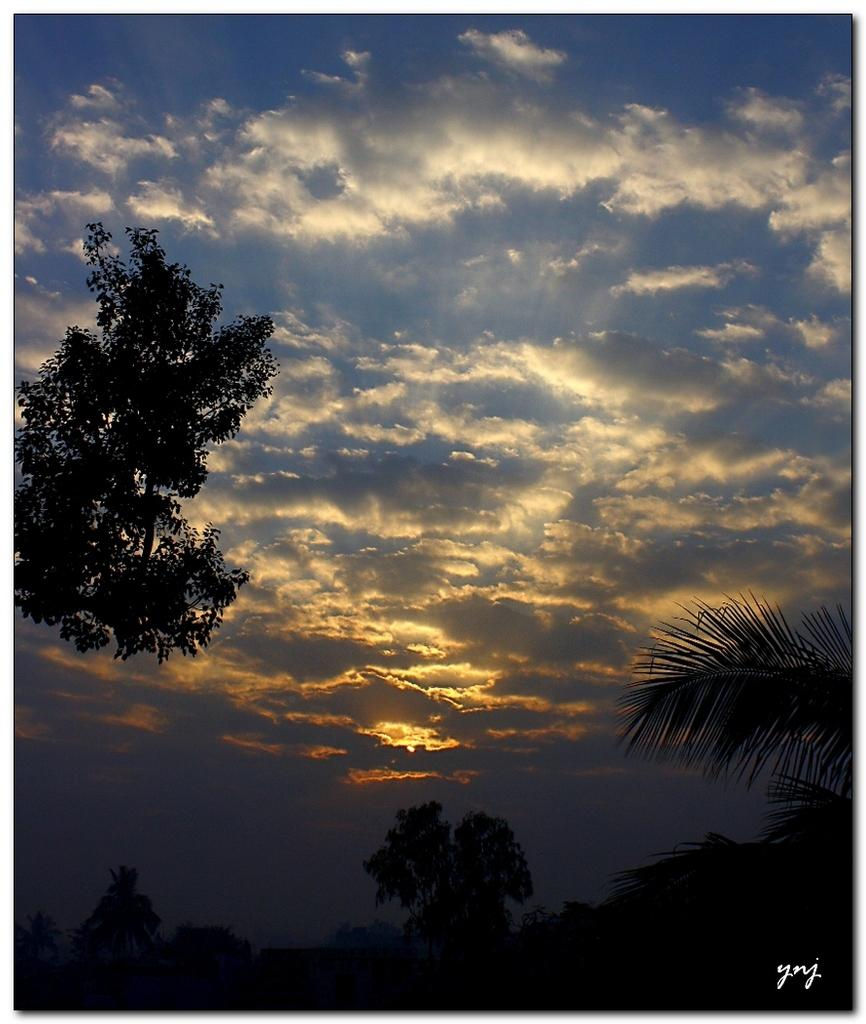What type of natural elements can be seen in the image? There are trees in the image. How would you describe the sky in the image? The sky is cloudy in the image. Where is the text located in the image? The text is visible at the right bottom of the image. Can you tell me how many toads are sitting on the branches of the trees in the image? There are no toads present in the image; it only features trees and a cloudy sky. 